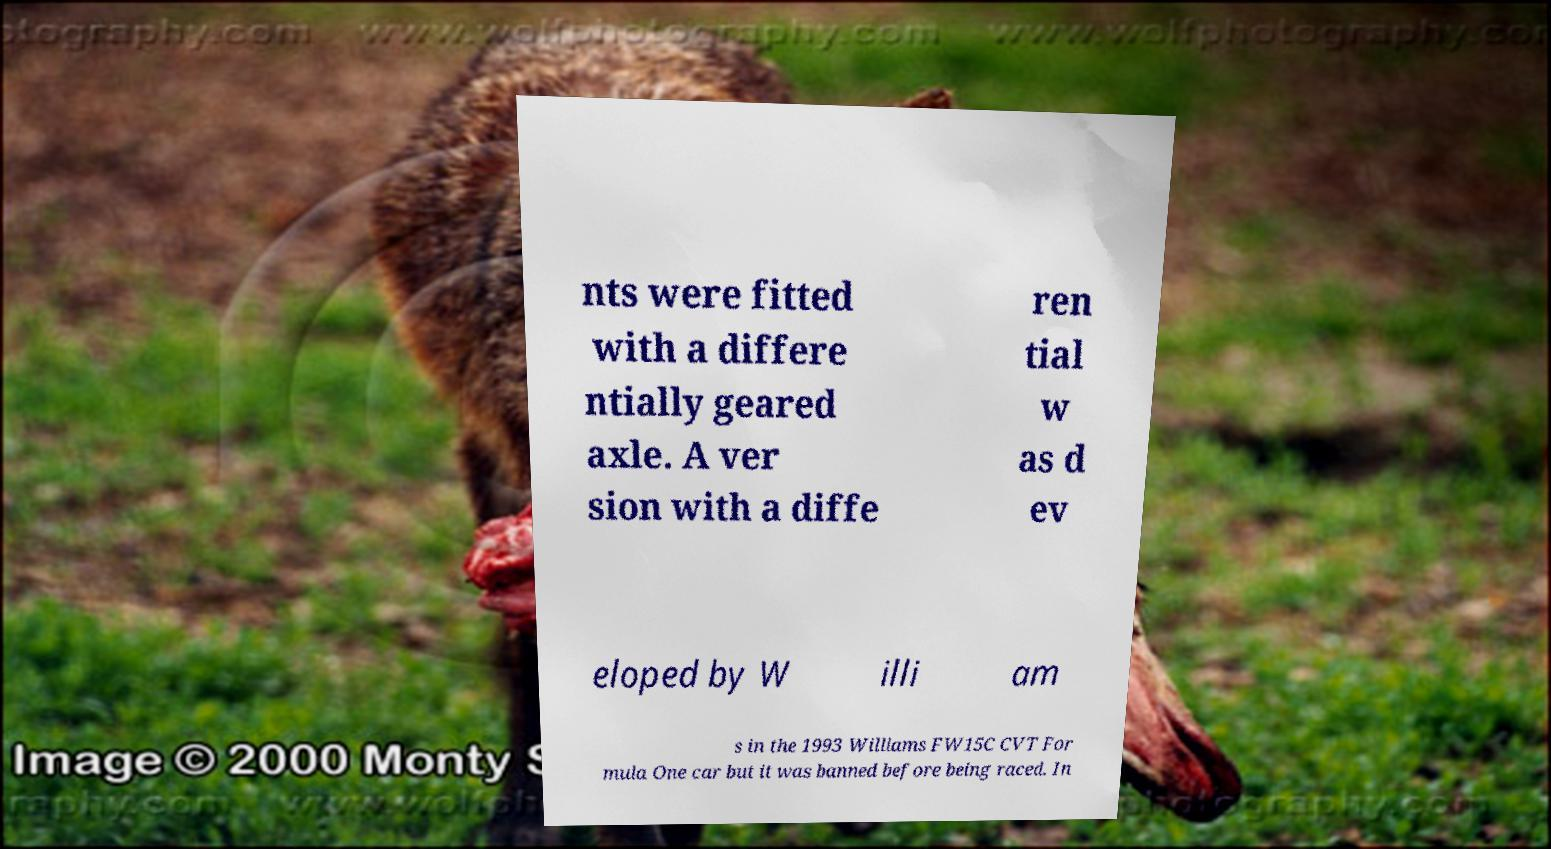Could you extract and type out the text from this image? nts were fitted with a differe ntially geared axle. A ver sion with a diffe ren tial w as d ev eloped by W illi am s in the 1993 Williams FW15C CVT For mula One car but it was banned before being raced. In 